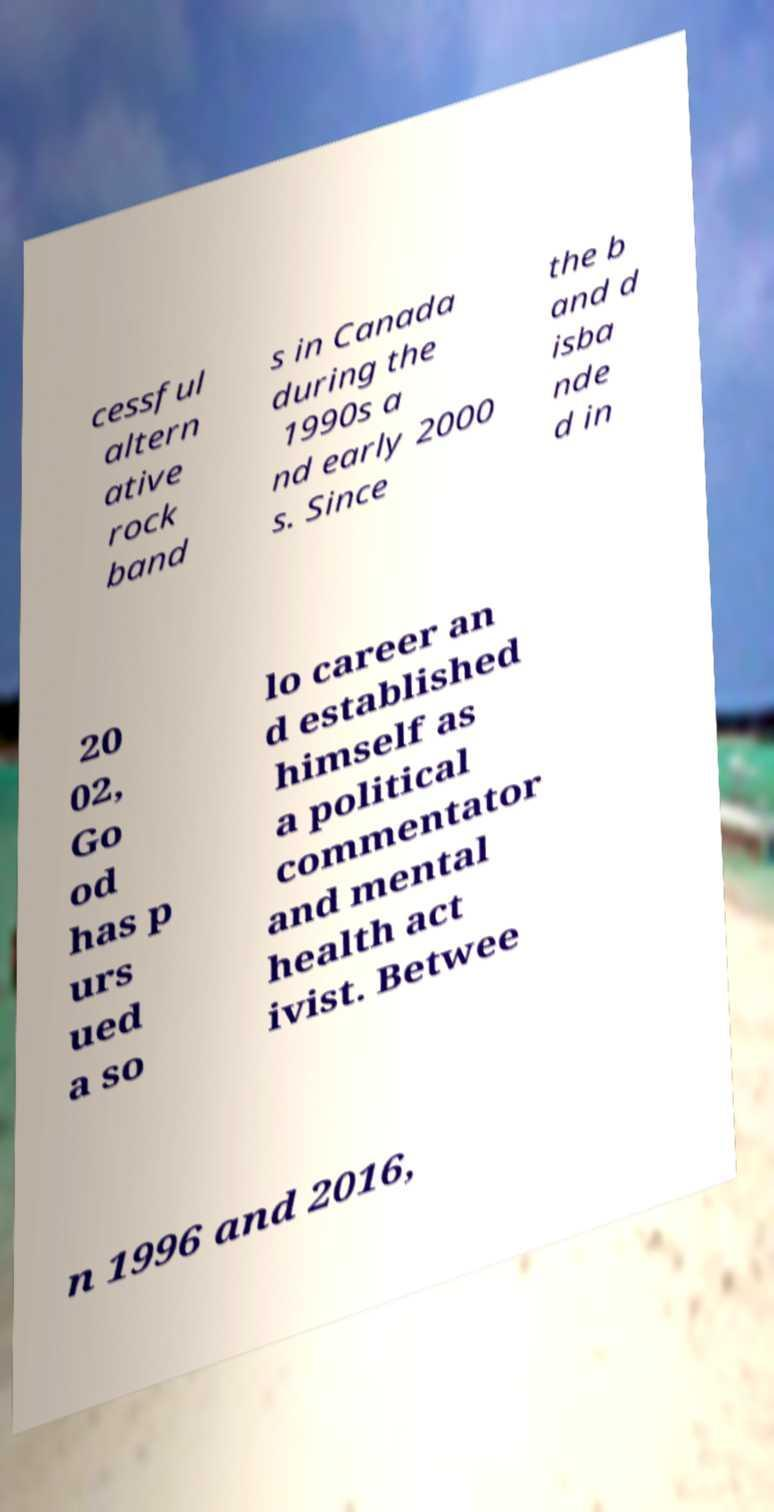There's text embedded in this image that I need extracted. Can you transcribe it verbatim? cessful altern ative rock band s in Canada during the 1990s a nd early 2000 s. Since the b and d isba nde d in 20 02, Go od has p urs ued a so lo career an d established himself as a political commentator and mental health act ivist. Betwee n 1996 and 2016, 